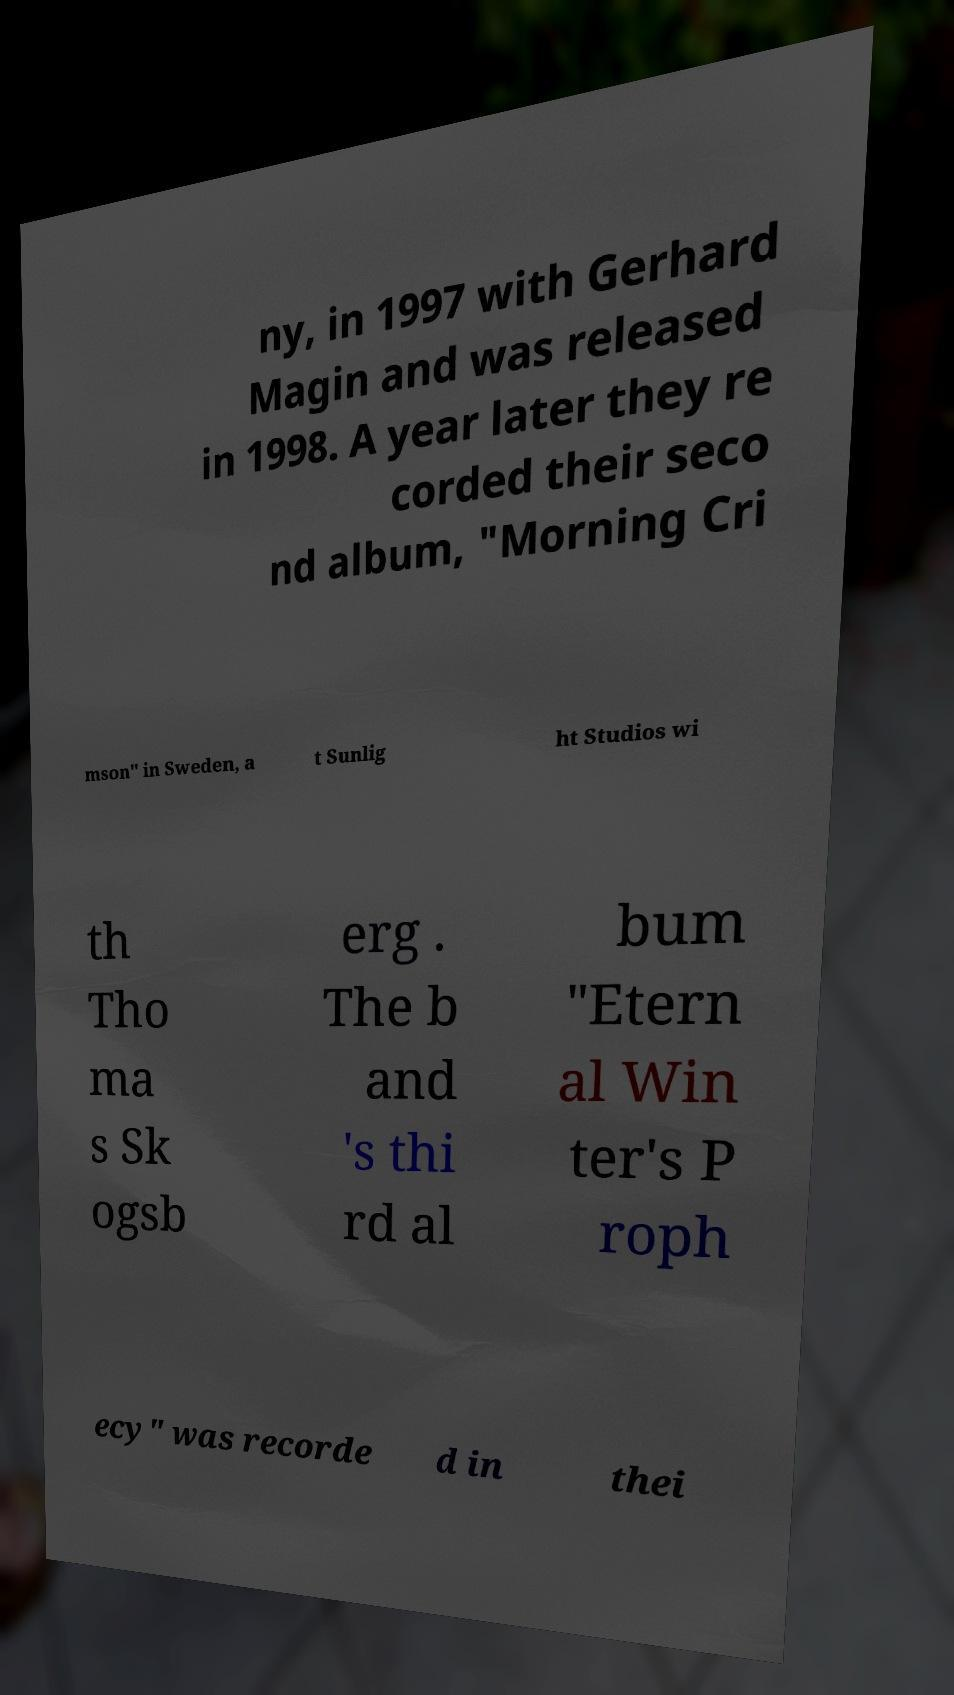Could you assist in decoding the text presented in this image and type it out clearly? ny, in 1997 with Gerhard Magin and was released in 1998. A year later they re corded their seco nd album, "Morning Cri mson" in Sweden, a t Sunlig ht Studios wi th Tho ma s Sk ogsb erg . The b and 's thi rd al bum "Etern al Win ter's P roph ecy" was recorde d in thei 